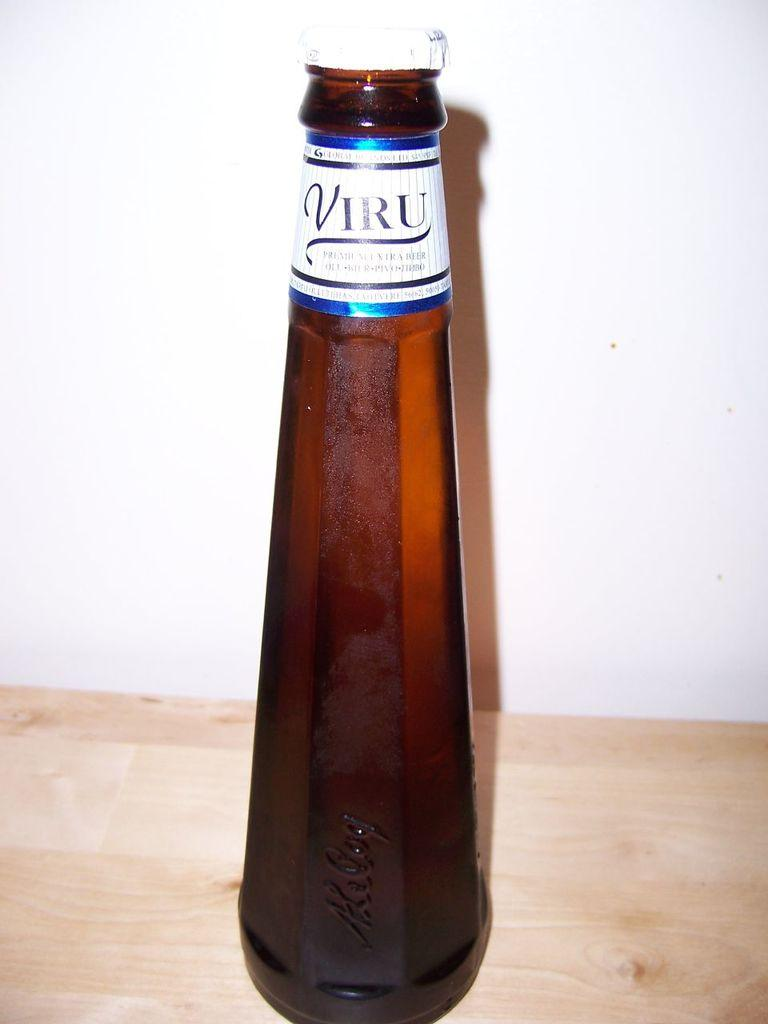Provide a one-sentence caption for the provided image. A brown bottle has a label at the top that states Viru. 